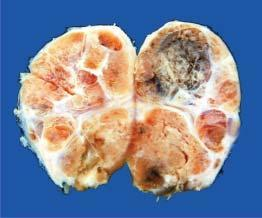what does cut surface show?
Answer the question using a single word or phrase. Multiple nodules separated from each other by incomplete fibrous septa 